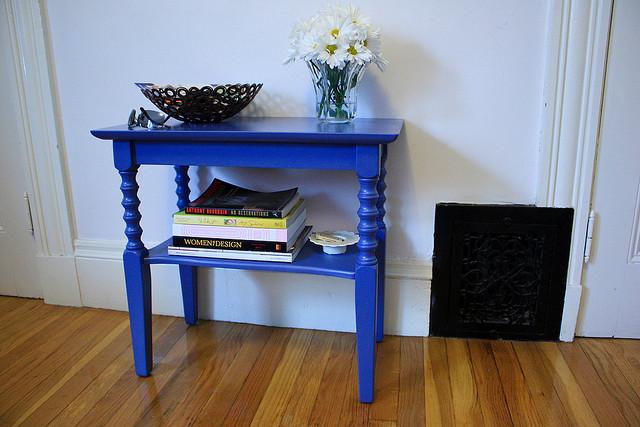Is there a contrast between the color of the table and the wall?
Short answer required. Yes. What color is the table?
Write a very short answer. Blue. What black thing is on the wall?
Keep it brief. Vent. 